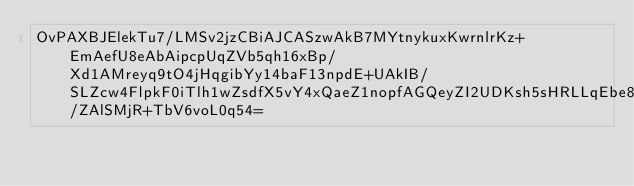<code> <loc_0><loc_0><loc_500><loc_500><_SML_>OvPAXBJElekTu7/LMSv2jzCBiAJCASzwAkB7MYtnykuxKwrnlrKz+EmAefU8eAbAipcpUqZVb5qh16xBp/Xd1AMreyq9tO4jHqgibYy14baF13npdE+UAkIB/SLZcw4FlpkF0iTlh1wZsdfX5vY4xQaeZ1nopfAGQeyZI2UDKsh5sHRLLqEbe8kCBif/ZAlSMjR+TbV6voL0q54=</code> 